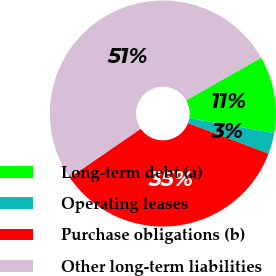Convert chart to OTSL. <chart><loc_0><loc_0><loc_500><loc_500><pie_chart><fcel>Long-term debt (a)<fcel>Operating leases<fcel>Purchase obligations (b)<fcel>Other long-term liabilities<nl><fcel>10.99%<fcel>3.02%<fcel>34.64%<fcel>51.35%<nl></chart> 